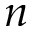Convert formula to latex. <formula><loc_0><loc_0><loc_500><loc_500>n</formula> 